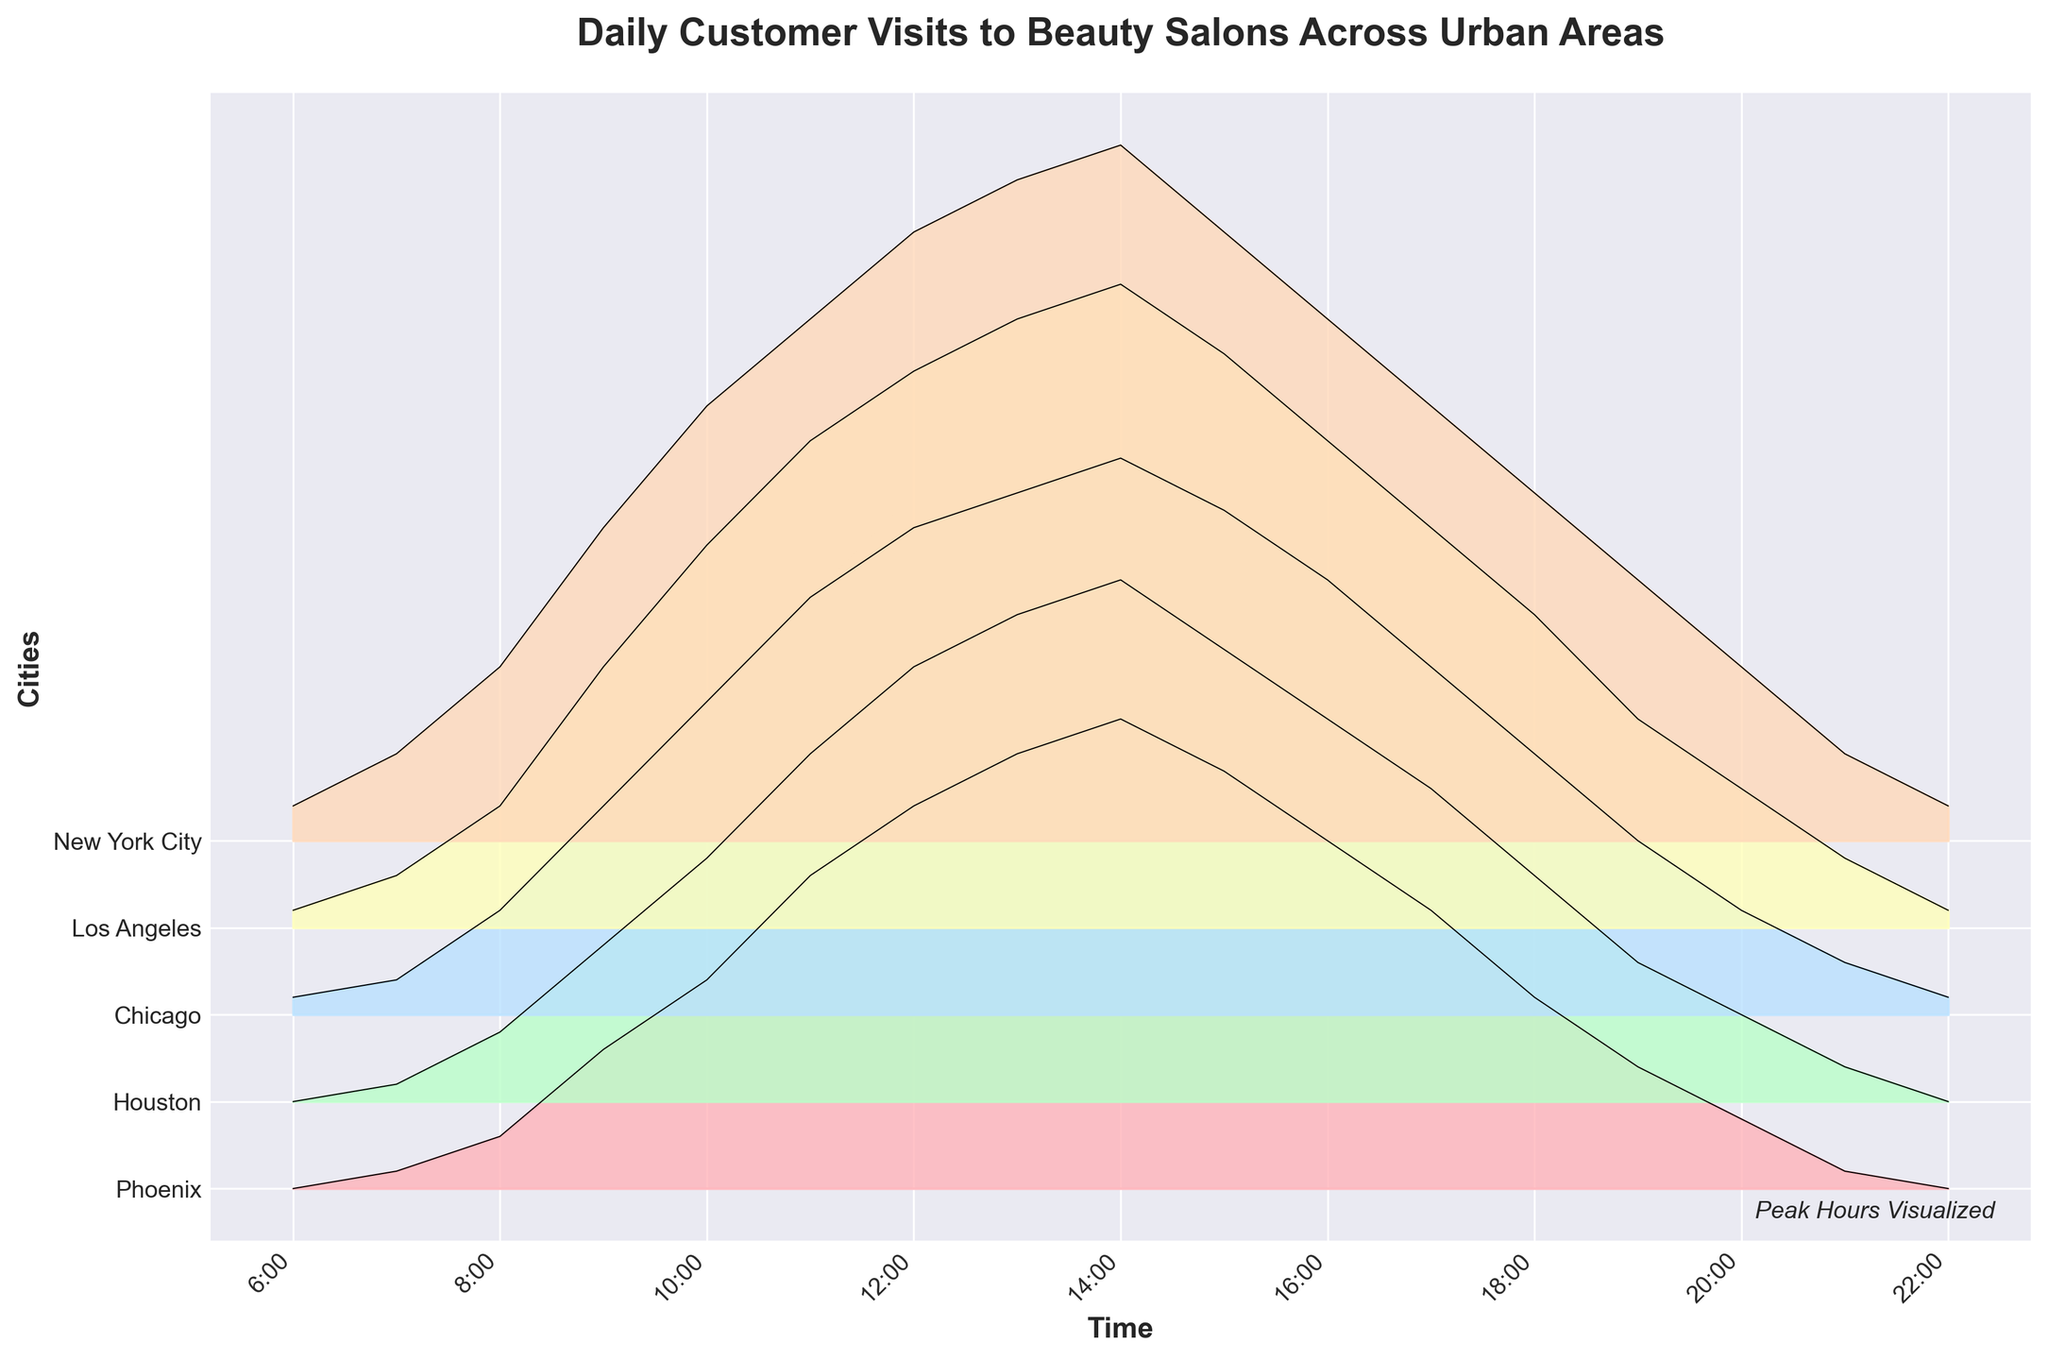What's the title of the figure? The title of the figure is prominently displayed at the top of the plot. This title helps in understanding what the figure represents.
Answer: Daily Customer Visits to Beauty Salons Across Urban Areas Which city shows the highest number of customer visits at 11:00 AM? At 11:00 AM, the different lines representing customer visits for each city reach different heights. The highest point for this time is observed for New York City.
Answer: New York City What time of the day does Los Angeles have the maximum customer visits? By examining the peak point of the Los Angeles line, we notice it reaches its highest value around 2:00 PM.
Answer: 2:00 PM How does the customer visit trend for Houston compare to that of Phoenix in the afternoon? In the afternoon, specifically around 1:00 PM to 3:00 PM, the trend for Houston shows higher customer visits compared to Phoenix when observing the relative height of their respective lines.
Answer: Houston is higher What’s the trend of customer visits in Chicago after 5:00 PM? By looking at the visual trend line for Chicago from 5:00 PM onwards, you can see that the number of visits decreases steadily.
Answer: Decreasing At what time does the overall customer visits across all cities begin to drop? The combined trend across all the cities shows a decline in customer visits starting after 2:00 PM.
Answer: After 2:00 PM Which city has the lowest customer visits at 8:00 AM? By checking the heights of the lines at 8:00 AM, Phoenix is the city with the fewest customer visits at this time.
Answer: Phoenix How does the peak of daily visits compare between New York City and Los Angeles? The peak in New York City is around 40 visits, while for Los Angeles it's about 37 visits, both happening around mid-afternoon. New York City has a slightly higher peak.
Answer: New York City is higher On average, during what time of the day do peak visits occur for most cities? Analyzing the respective peaks for each city's ridges, the mid-afternoon period (around 2:00 PM) usually shows the peak visits.
Answer: Mid-afternoon, around 2:00 PM 